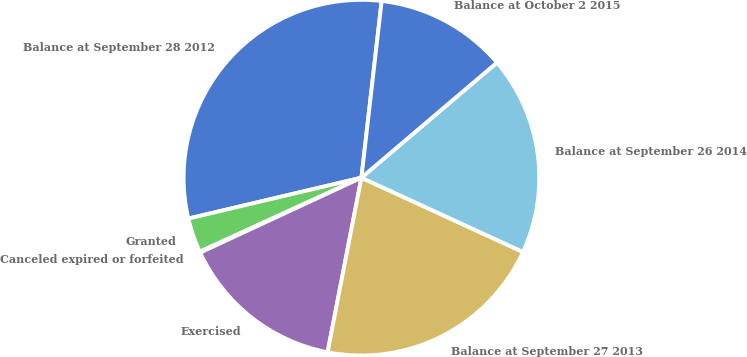Convert chart. <chart><loc_0><loc_0><loc_500><loc_500><pie_chart><fcel>Balance at September 28 2012<fcel>Granted<fcel>Canceled expired or forfeited<fcel>Exercised<fcel>Balance at September 27 2013<fcel>Balance at September 26 2014<fcel>Balance at October 2 2015<nl><fcel>30.51%<fcel>3.14%<fcel>0.09%<fcel>15.03%<fcel>21.19%<fcel>18.07%<fcel>11.98%<nl></chart> 